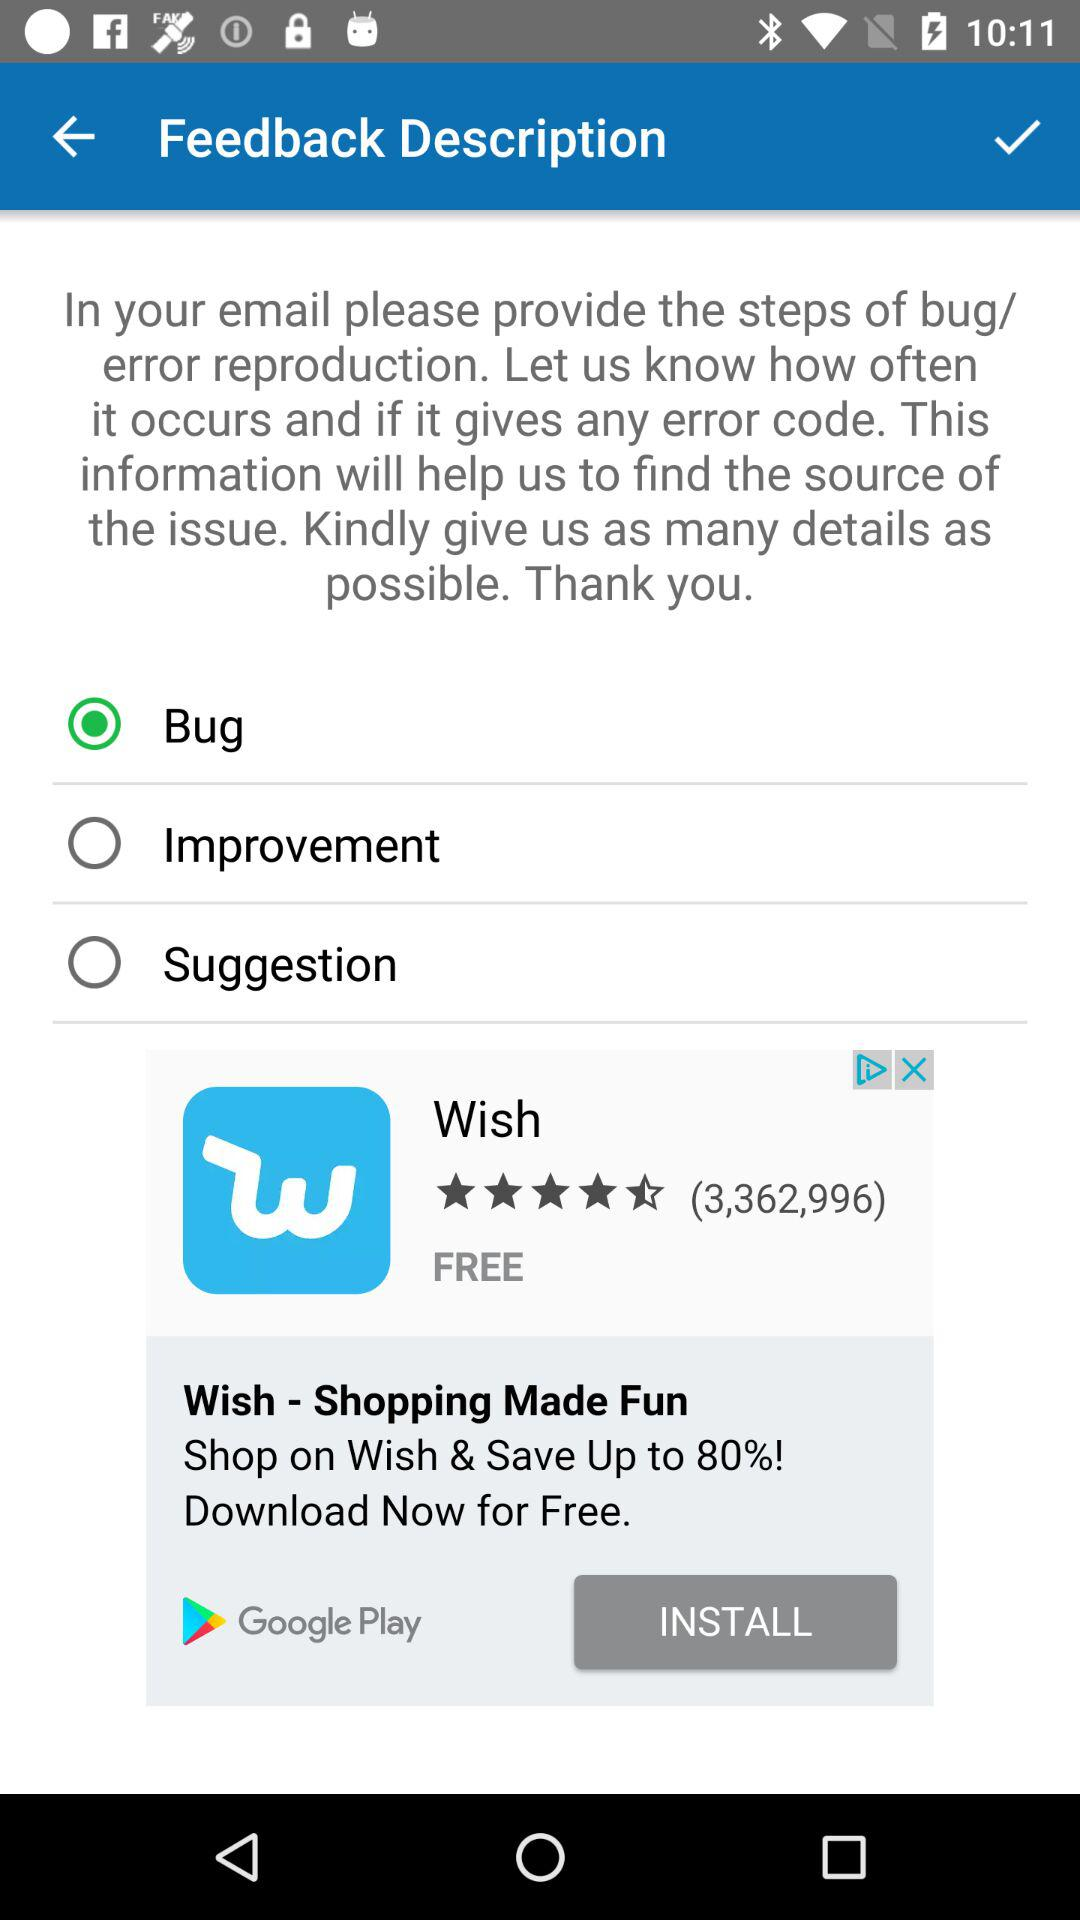What is the user's name?
When the provided information is insufficient, respond with <no answer>. <no answer> 